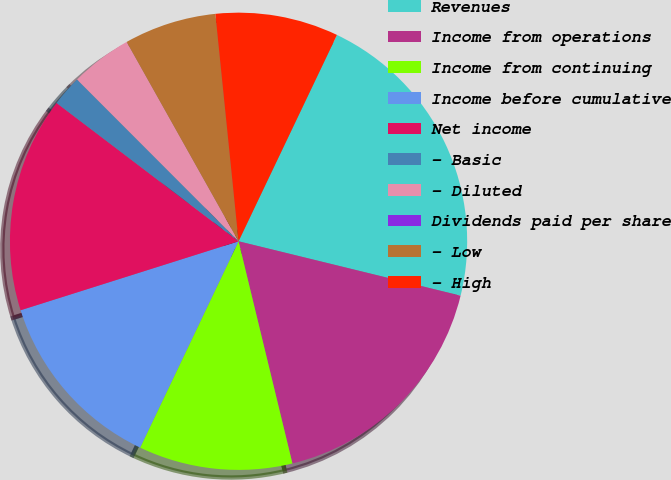<chart> <loc_0><loc_0><loc_500><loc_500><pie_chart><fcel>Revenues<fcel>Income from operations<fcel>Income from continuing<fcel>Income before cumulative<fcel>Net income<fcel>- Basic<fcel>- Diluted<fcel>Dividends paid per share<fcel>- Low<fcel>- High<nl><fcel>21.74%<fcel>17.39%<fcel>10.87%<fcel>13.04%<fcel>15.22%<fcel>2.17%<fcel>4.35%<fcel>0.0%<fcel>6.52%<fcel>8.7%<nl></chart> 